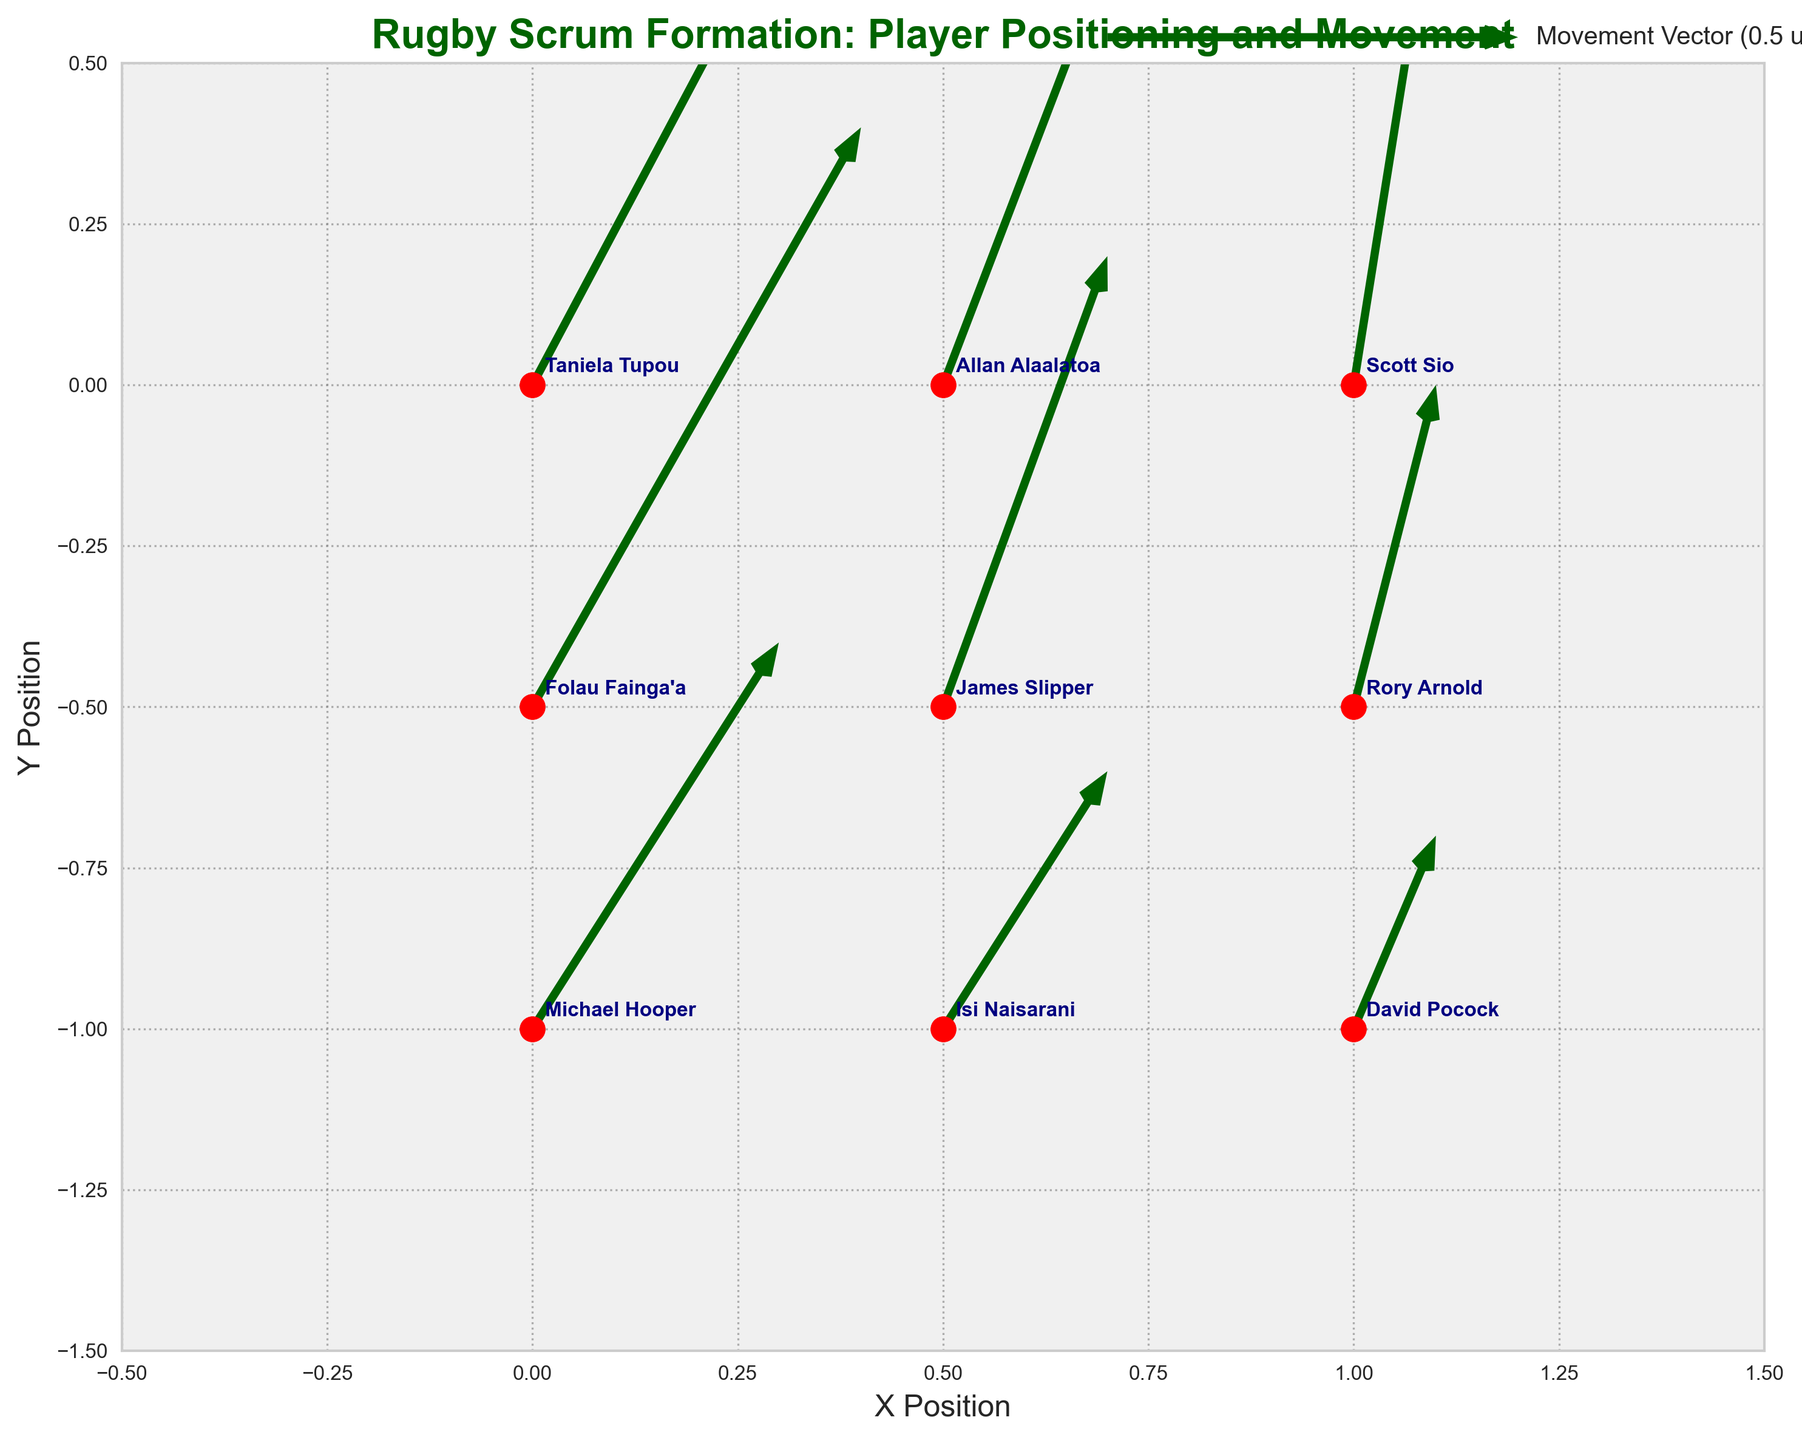How many players are displayed in the figure? There are nine individual markers in the plot, each labeled with a player's name. This indicates there are nine players displayed in the figure.
Answer: Nine What is the main color used for the vectors indicating movement? The quiver plot uses dark green vectors to indicate the direction and magnitude of player movement. This is consistent across all movement vectors in the plot.
Answer: Dark green Who has the highest movement vector in both magnitude and direction? Taniela Tupou has the vector (0.5, 1.2), which has the highest magnitude among all players. You determine this by comparing the length of each vector, and Taniela Tupou’s stands out as the longest.
Answer: Taniela Tupou Which player is located at the position (0.5, -0.5)? By looking at the plot, you can see that James Slipper is the player positioned at coordinates (0.5, -0.5).
Answer: James Slipper What is the combined vertical vector movement for Michael Hooper and David Pocock? Michael Hooper's vertical movement is 0.6 and David Pocock's is 0.3. Adding both of these vertical movements yields a total combined vertical vector of 0.6 + 0.3 = 0.9.
Answer: 0.9 Who has a movement vector closest to (0, 0)? Scott Sio’s vector (0.1, 0.8) has the smallest magnitude vector after performing the magnitude calculation using the Pythagorean theorem for all vectors.
Answer: Scott Sio Compare the direction of movement between Allan Alaalatoa and Folau Fainga’a. Who is moving more upward (positive y-direction)? Allan Alaalatoa's movement vector is (0.3, 1.0) and Folau Fainga’a’s is (0.4, 0.9). Comparing the y-components, Allan Alaalatoa is moving more upward because 1.0 > 0.9.
Answer: Allan Alaalatoa Which player has the smallest horizontal movement component (u)? Comparing all the horizontal components, Scott Sio, Rory Arnold, and David Pocock each have the smallest horizontal movement component of 0.1.
Answer: Scott Sio, Rory Arnold, David Pocock What is the average horizontal movement (u) of all players? To find the average, sum all horizontal vectors: 0.5 + 0.3 + 0.1 + 0.4 + 0.2 + 0.1 + 0.3 + 0.2 + 0.1 = 2.2. Then divide by the number of players, 2.2/9 = 0.244.
Answer: 0.244 What grid style is used in the plot background? The grid lines are gray, dotted (colon style), and have an alpha transparency setting of 0.6, providing a subtle background grid.
Answer: Gray dotted grid 